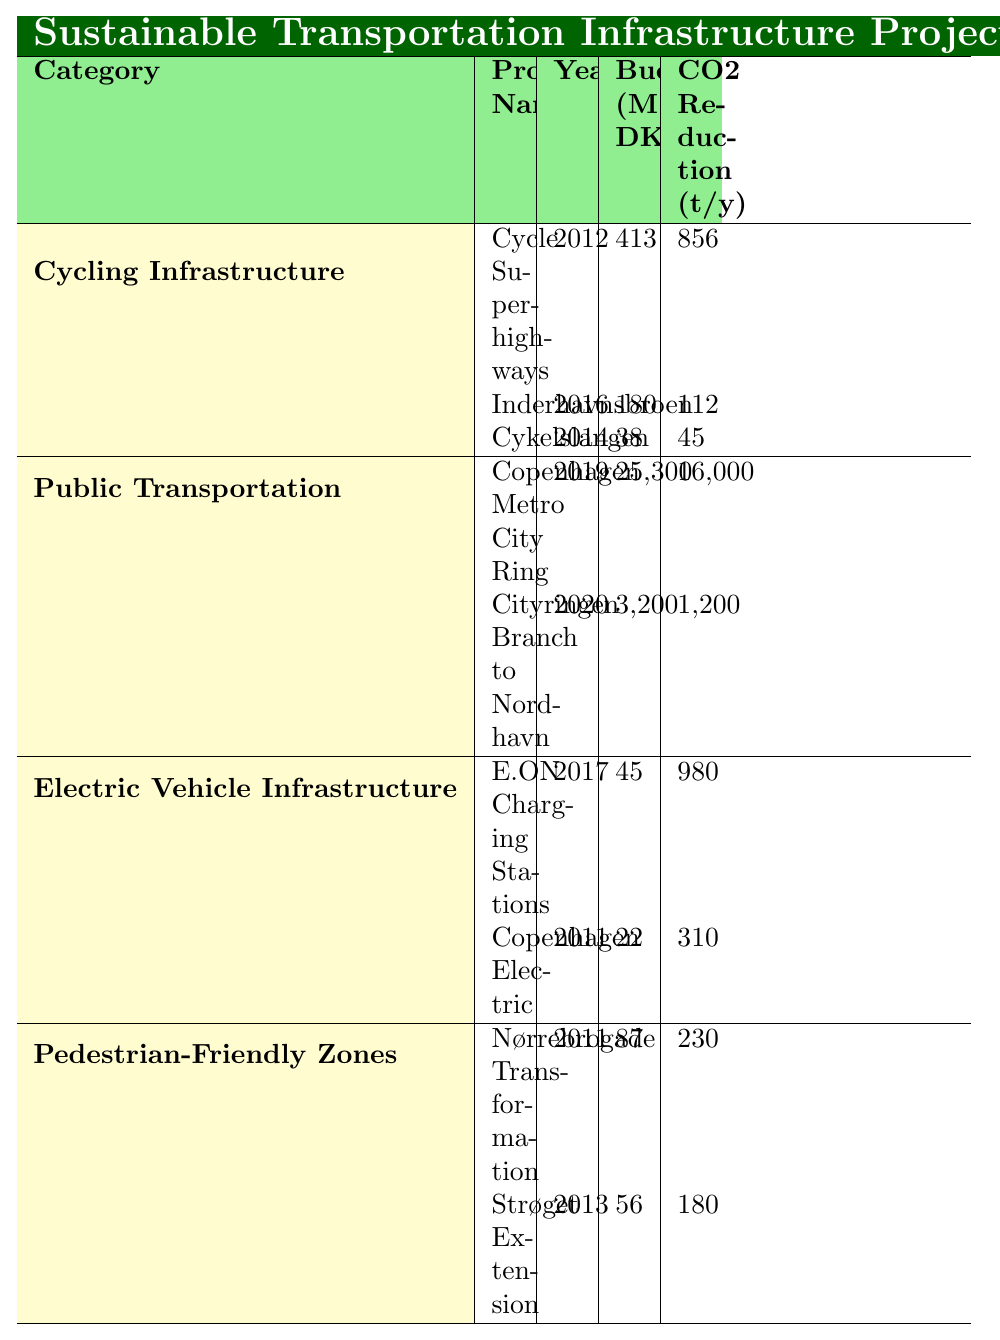What is the total budget allocated for Cycling Infrastructure projects? The budget for Cycling Infrastructure includes: Cycle Superhighways (413 million DKK), Inderhavnsbroen (180 million DKK), and Cykelslangen (38 million DKK). Summing these gives 413 + 180 + 38 = 631 million DKK.
Answer: 631 million DKK Which project had the highest CO2 reduction and what was its value? By reviewing the CO2 reduction values, Copenhagen Metro City Ring has the highest at 16,000 tons/year, compared to other projects in the table.
Answer: 16,000 tons/year Is the budget for the E.ON Charging Stations higher than for Copenhagen Electric? The budget for E.ON Charging Stations is 45 million DKK and for Copenhagen Electric is 22 million DKK. Since 45 > 22, the budget for E.ON Charging Stations is indeed higher.
Answer: Yes What is the average CO2 reduction across all the projects listed in the table? The CO2 reduction values are 856, 112, 45, 16000, 1200, 980, 310, 230, and 180. Summing these = 16,000 + 980 + 310 + 230 + 180 + 856 + 112 + 45 = 17,713 tons/year. There are 8 projects, so the average is 17,713 / 8 = 2,214.125 tons/year.
Answer: 2,214.125 tons/year How many kilometers of cycling infrastructure were developed with the Cycle Superhighways project? Cycle Superhighways was developed with a length of 167 km as indicated in the table under Cycling Infrastructure projects.
Answer: 167 km Which category has the most number of projects listed? Reviewing the categories: Cycling Infrastructure has 3 projects, Public Transportation has 2, Electric Vehicle Infrastructure has 2, and Pedestrian-Friendly Zones has 2 projects. Therefore, Cycling Infrastructure has the most projects with 3.
Answer: Cycling Infrastructure If you combine the CO2 reduction from the two Public Transportation projects, what is the total reduction? The CO2 reduction for Copenhagen Metro City Ring is 16,000 tons/year and Cityringen Branch to Nordhavn is 1,200 tons/year. Adding these gives 16,000 + 1,200 = 17,200 tons/year for Public Transportation.
Answer: 17,200 tons/year What percentage of the total budget is allocated to the Cycling Infrastructure category? Total budget comprises: Cycle Superhighways (413), Inderhavnsbroen (180), Cykelslangen (38), Copenhagen Metro City Ring (25,300), Cityringen Branch to Nordhavn (3,200), E.ON Charging Stations (45), Copenhagen Electric (22), Nørrebrogade Transformation (87), and Strøget Extension (56). The total budget = 25,300 + 3,200 + 631 = 29,131 million DKK for all projects. The cycling budget = 631 million DKK, so (631/29131) * 100 = 2.16%.
Answer: 2.16% Is it true that the Nørrebrogade Transformation project was created in 2013? The table shows that Nørrebrogade Transformation was actually initiated in 2011, not 2013, therefore the statement is false.
Answer: No Which project was launched in the same year as Cykelslangen? Cykelslangen was launched in 2014, and looking through the table confirms that no other project is listed for the same year, thus it is the only one from 2014.
Answer: None 